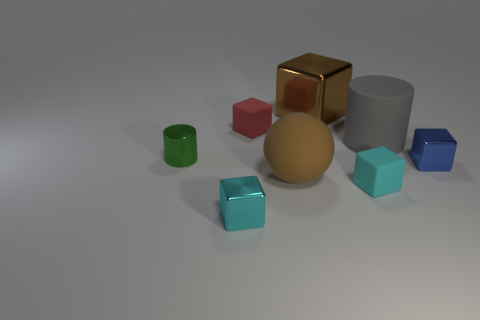How many red rubber cubes are behind the brown object that is behind the tiny metallic cylinder?
Make the answer very short. 0. There is a small matte thing behind the thing that is to the right of the big gray rubber cylinder; is there a rubber object in front of it?
Ensure brevity in your answer.  Yes. What is the material of the red thing that is the same shape as the small blue metal object?
Offer a very short reply. Rubber. Is the material of the gray thing the same as the cyan block in front of the small cyan matte block?
Ensure brevity in your answer.  No. What shape is the big brown thing in front of the brown thing behind the big gray cylinder?
Give a very brief answer. Sphere. How many big things are cyan metallic blocks or cyan rubber things?
Make the answer very short. 0. How many other small rubber objects have the same shape as the tiny cyan matte thing?
Give a very brief answer. 1. Is the shape of the tiny cyan metal object the same as the large object that is behind the big gray matte cylinder?
Provide a short and direct response. Yes. There is a tiny blue object; what number of tiny cubes are to the left of it?
Offer a terse response. 3. Are there any matte blocks of the same size as the blue object?
Your answer should be compact. Yes. 